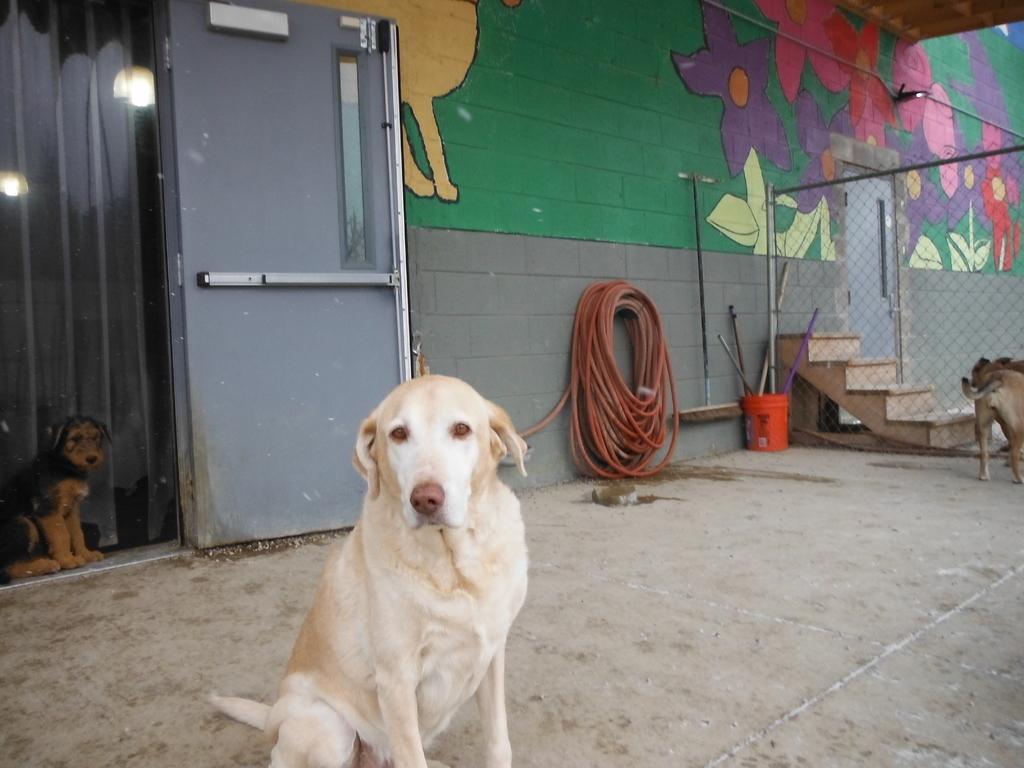How would you summarize this image in a sentence or two? In this image we can see some dogs on the ground. We can also see some doors, a wall with some painting and a pipe hanged to it, some lights, some sticks placed in a bucket, a staircase and a metal fence. 